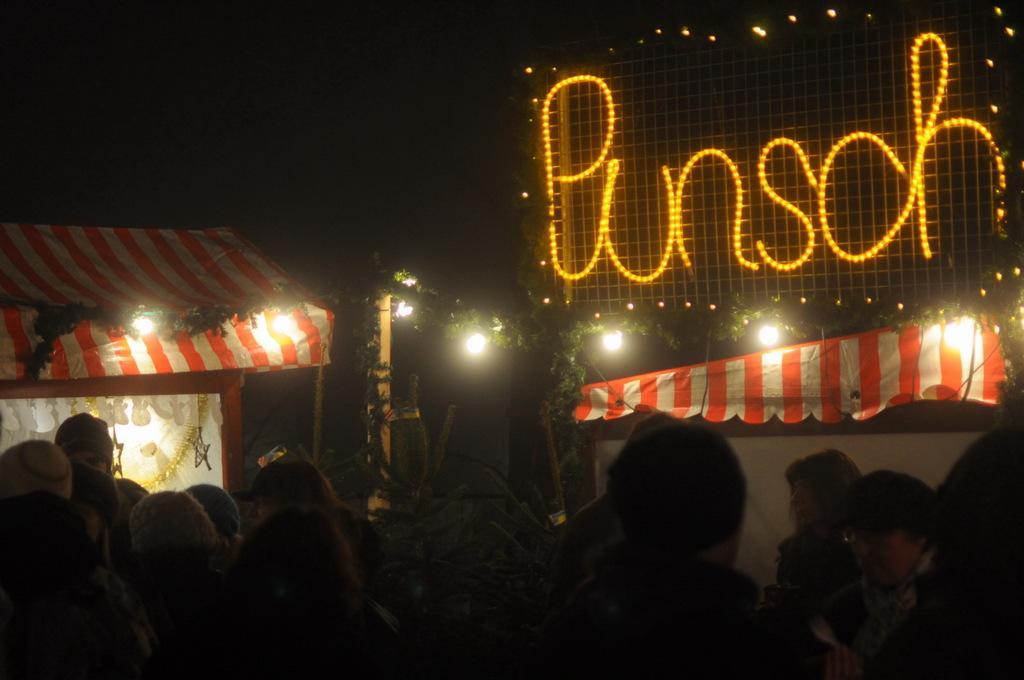Describe this image in one or two sentences. In this image we can see people, plants, tents, pole, lights, and letters on the mesh. There is a dark background. 